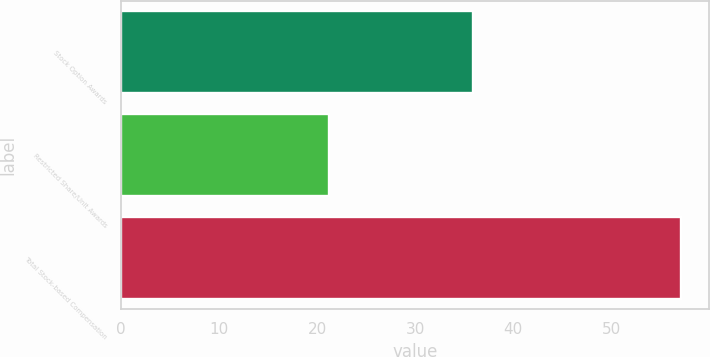Convert chart. <chart><loc_0><loc_0><loc_500><loc_500><bar_chart><fcel>Stock Option Awards<fcel>Restricted Share/Unit Awards<fcel>Total Stock-based Compensation<nl><fcel>35.9<fcel>21.2<fcel>57.1<nl></chart> 